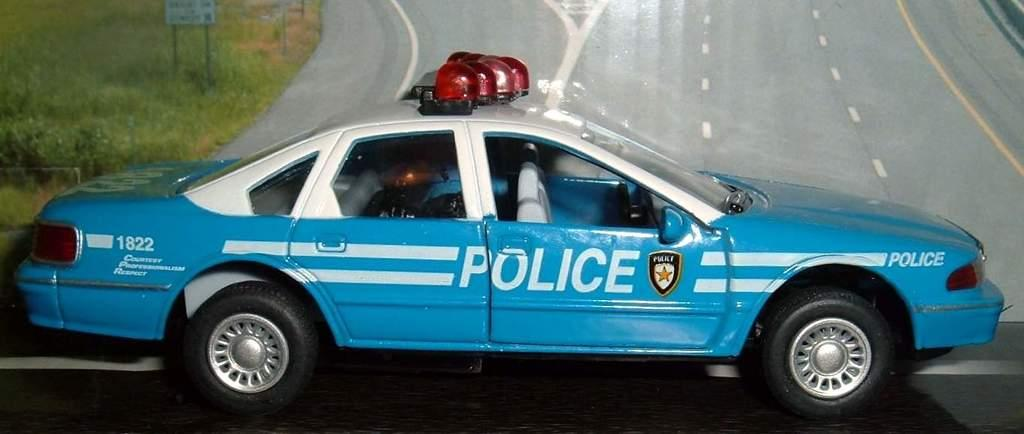What type of vehicle is in the image? There is a police car in the image. What else can be seen in the image besides the police car? There is a poster in the image. What is depicted on the poster? The poster has an image of a road on it. What type of heat can be felt coming from the police car in the image? There is no indication of heat or temperature in the image, and therefore it cannot be determined from the image. 